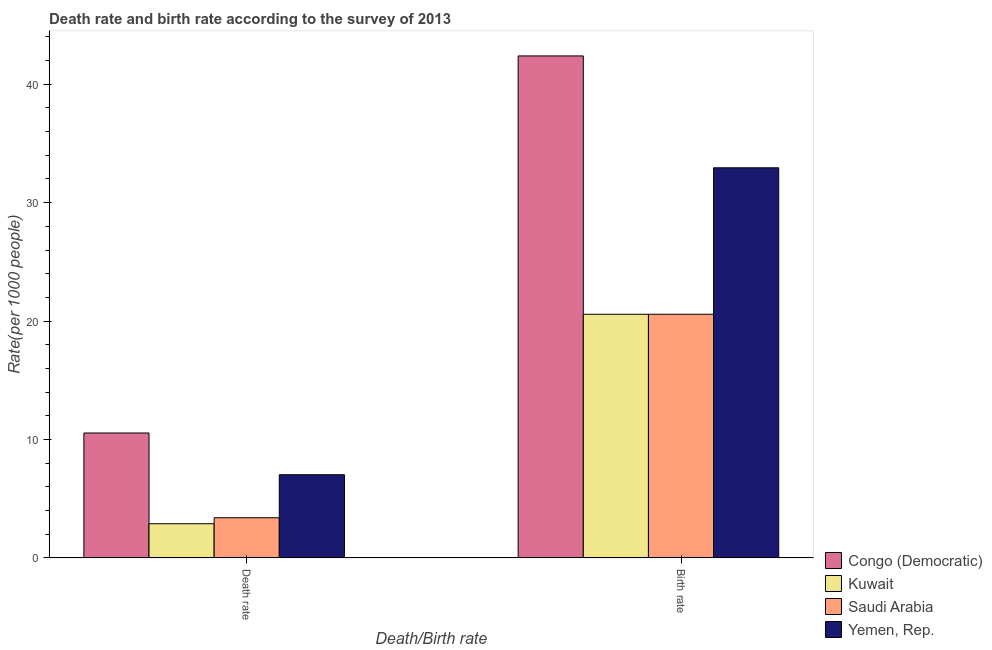How many different coloured bars are there?
Offer a very short reply. 4. Are the number of bars per tick equal to the number of legend labels?
Offer a terse response. Yes. Are the number of bars on each tick of the X-axis equal?
Offer a terse response. Yes. How many bars are there on the 1st tick from the left?
Give a very brief answer. 4. How many bars are there on the 2nd tick from the right?
Your answer should be compact. 4. What is the label of the 2nd group of bars from the left?
Keep it short and to the point. Birth rate. What is the birth rate in Kuwait?
Provide a short and direct response. 20.57. Across all countries, what is the maximum birth rate?
Your answer should be compact. 42.39. Across all countries, what is the minimum death rate?
Your response must be concise. 2.88. In which country was the birth rate maximum?
Provide a short and direct response. Congo (Democratic). In which country was the birth rate minimum?
Give a very brief answer. Kuwait. What is the total birth rate in the graph?
Provide a succinct answer. 116.49. What is the difference between the death rate in Kuwait and that in Congo (Democratic)?
Offer a very short reply. -7.66. What is the difference between the death rate in Congo (Democratic) and the birth rate in Yemen, Rep.?
Keep it short and to the point. -22.4. What is the average death rate per country?
Keep it short and to the point. 5.96. What is the difference between the birth rate and death rate in Kuwait?
Offer a terse response. 17.69. What is the ratio of the death rate in Yemen, Rep. to that in Congo (Democratic)?
Provide a succinct answer. 0.67. Is the death rate in Kuwait less than that in Yemen, Rep.?
Offer a terse response. Yes. In how many countries, is the death rate greater than the average death rate taken over all countries?
Provide a succinct answer. 2. What does the 2nd bar from the left in Death rate represents?
Offer a terse response. Kuwait. What does the 4th bar from the right in Death rate represents?
Provide a short and direct response. Congo (Democratic). How many bars are there?
Your response must be concise. 8. Are all the bars in the graph horizontal?
Make the answer very short. No. What is the difference between two consecutive major ticks on the Y-axis?
Ensure brevity in your answer.  10. Are the values on the major ticks of Y-axis written in scientific E-notation?
Offer a terse response. No. Does the graph contain grids?
Make the answer very short. No. Where does the legend appear in the graph?
Give a very brief answer. Bottom right. What is the title of the graph?
Ensure brevity in your answer.  Death rate and birth rate according to the survey of 2013. What is the label or title of the X-axis?
Your response must be concise. Death/Birth rate. What is the label or title of the Y-axis?
Give a very brief answer. Rate(per 1000 people). What is the Rate(per 1000 people) of Congo (Democratic) in Death rate?
Provide a short and direct response. 10.55. What is the Rate(per 1000 people) in Kuwait in Death rate?
Your answer should be compact. 2.88. What is the Rate(per 1000 people) of Saudi Arabia in Death rate?
Your answer should be very brief. 3.39. What is the Rate(per 1000 people) of Yemen, Rep. in Death rate?
Your response must be concise. 7.02. What is the Rate(per 1000 people) of Congo (Democratic) in Birth rate?
Ensure brevity in your answer.  42.39. What is the Rate(per 1000 people) of Kuwait in Birth rate?
Provide a short and direct response. 20.57. What is the Rate(per 1000 people) of Saudi Arabia in Birth rate?
Ensure brevity in your answer.  20.58. What is the Rate(per 1000 people) in Yemen, Rep. in Birth rate?
Provide a short and direct response. 32.95. Across all Death/Birth rate, what is the maximum Rate(per 1000 people) of Congo (Democratic)?
Your answer should be compact. 42.39. Across all Death/Birth rate, what is the maximum Rate(per 1000 people) of Kuwait?
Give a very brief answer. 20.57. Across all Death/Birth rate, what is the maximum Rate(per 1000 people) of Saudi Arabia?
Keep it short and to the point. 20.58. Across all Death/Birth rate, what is the maximum Rate(per 1000 people) of Yemen, Rep.?
Make the answer very short. 32.95. Across all Death/Birth rate, what is the minimum Rate(per 1000 people) in Congo (Democratic)?
Ensure brevity in your answer.  10.55. Across all Death/Birth rate, what is the minimum Rate(per 1000 people) of Kuwait?
Provide a short and direct response. 2.88. Across all Death/Birth rate, what is the minimum Rate(per 1000 people) of Saudi Arabia?
Your response must be concise. 3.39. Across all Death/Birth rate, what is the minimum Rate(per 1000 people) in Yemen, Rep.?
Your response must be concise. 7.02. What is the total Rate(per 1000 people) of Congo (Democratic) in the graph?
Make the answer very short. 52.94. What is the total Rate(per 1000 people) of Kuwait in the graph?
Your response must be concise. 23.46. What is the total Rate(per 1000 people) in Saudi Arabia in the graph?
Ensure brevity in your answer.  23.97. What is the total Rate(per 1000 people) of Yemen, Rep. in the graph?
Keep it short and to the point. 39.97. What is the difference between the Rate(per 1000 people) of Congo (Democratic) in Death rate and that in Birth rate?
Give a very brief answer. -31.84. What is the difference between the Rate(per 1000 people) in Kuwait in Death rate and that in Birth rate?
Your response must be concise. -17.69. What is the difference between the Rate(per 1000 people) in Saudi Arabia in Death rate and that in Birth rate?
Provide a succinct answer. -17.18. What is the difference between the Rate(per 1000 people) of Yemen, Rep. in Death rate and that in Birth rate?
Offer a very short reply. -25.92. What is the difference between the Rate(per 1000 people) of Congo (Democratic) in Death rate and the Rate(per 1000 people) of Kuwait in Birth rate?
Your answer should be very brief. -10.03. What is the difference between the Rate(per 1000 people) in Congo (Democratic) in Death rate and the Rate(per 1000 people) in Saudi Arabia in Birth rate?
Your answer should be very brief. -10.03. What is the difference between the Rate(per 1000 people) in Congo (Democratic) in Death rate and the Rate(per 1000 people) in Yemen, Rep. in Birth rate?
Offer a terse response. -22.4. What is the difference between the Rate(per 1000 people) in Kuwait in Death rate and the Rate(per 1000 people) in Saudi Arabia in Birth rate?
Ensure brevity in your answer.  -17.69. What is the difference between the Rate(per 1000 people) in Kuwait in Death rate and the Rate(per 1000 people) in Yemen, Rep. in Birth rate?
Provide a succinct answer. -30.06. What is the difference between the Rate(per 1000 people) of Saudi Arabia in Death rate and the Rate(per 1000 people) of Yemen, Rep. in Birth rate?
Provide a succinct answer. -29.55. What is the average Rate(per 1000 people) of Congo (Democratic) per Death/Birth rate?
Keep it short and to the point. 26.47. What is the average Rate(per 1000 people) of Kuwait per Death/Birth rate?
Provide a short and direct response. 11.73. What is the average Rate(per 1000 people) in Saudi Arabia per Death/Birth rate?
Offer a very short reply. 11.98. What is the average Rate(per 1000 people) in Yemen, Rep. per Death/Birth rate?
Your answer should be compact. 19.99. What is the difference between the Rate(per 1000 people) of Congo (Democratic) and Rate(per 1000 people) of Kuwait in Death rate?
Provide a short and direct response. 7.66. What is the difference between the Rate(per 1000 people) of Congo (Democratic) and Rate(per 1000 people) of Saudi Arabia in Death rate?
Make the answer very short. 7.16. What is the difference between the Rate(per 1000 people) in Congo (Democratic) and Rate(per 1000 people) in Yemen, Rep. in Death rate?
Your answer should be very brief. 3.52. What is the difference between the Rate(per 1000 people) of Kuwait and Rate(per 1000 people) of Saudi Arabia in Death rate?
Your answer should be very brief. -0.51. What is the difference between the Rate(per 1000 people) of Kuwait and Rate(per 1000 people) of Yemen, Rep. in Death rate?
Keep it short and to the point. -4.14. What is the difference between the Rate(per 1000 people) in Saudi Arabia and Rate(per 1000 people) in Yemen, Rep. in Death rate?
Your response must be concise. -3.63. What is the difference between the Rate(per 1000 people) of Congo (Democratic) and Rate(per 1000 people) of Kuwait in Birth rate?
Offer a terse response. 21.82. What is the difference between the Rate(per 1000 people) of Congo (Democratic) and Rate(per 1000 people) of Saudi Arabia in Birth rate?
Offer a terse response. 21.82. What is the difference between the Rate(per 1000 people) of Congo (Democratic) and Rate(per 1000 people) of Yemen, Rep. in Birth rate?
Provide a succinct answer. 9.45. What is the difference between the Rate(per 1000 people) of Kuwait and Rate(per 1000 people) of Saudi Arabia in Birth rate?
Provide a succinct answer. -0. What is the difference between the Rate(per 1000 people) in Kuwait and Rate(per 1000 people) in Yemen, Rep. in Birth rate?
Offer a terse response. -12.37. What is the difference between the Rate(per 1000 people) in Saudi Arabia and Rate(per 1000 people) in Yemen, Rep. in Birth rate?
Ensure brevity in your answer.  -12.37. What is the ratio of the Rate(per 1000 people) of Congo (Democratic) in Death rate to that in Birth rate?
Your answer should be very brief. 0.25. What is the ratio of the Rate(per 1000 people) in Kuwait in Death rate to that in Birth rate?
Provide a short and direct response. 0.14. What is the ratio of the Rate(per 1000 people) in Saudi Arabia in Death rate to that in Birth rate?
Make the answer very short. 0.16. What is the ratio of the Rate(per 1000 people) of Yemen, Rep. in Death rate to that in Birth rate?
Make the answer very short. 0.21. What is the difference between the highest and the second highest Rate(per 1000 people) of Congo (Democratic)?
Provide a succinct answer. 31.84. What is the difference between the highest and the second highest Rate(per 1000 people) in Kuwait?
Keep it short and to the point. 17.69. What is the difference between the highest and the second highest Rate(per 1000 people) of Saudi Arabia?
Give a very brief answer. 17.18. What is the difference between the highest and the second highest Rate(per 1000 people) in Yemen, Rep.?
Make the answer very short. 25.92. What is the difference between the highest and the lowest Rate(per 1000 people) of Congo (Democratic)?
Provide a short and direct response. 31.84. What is the difference between the highest and the lowest Rate(per 1000 people) in Kuwait?
Keep it short and to the point. 17.69. What is the difference between the highest and the lowest Rate(per 1000 people) of Saudi Arabia?
Provide a short and direct response. 17.18. What is the difference between the highest and the lowest Rate(per 1000 people) in Yemen, Rep.?
Provide a short and direct response. 25.92. 